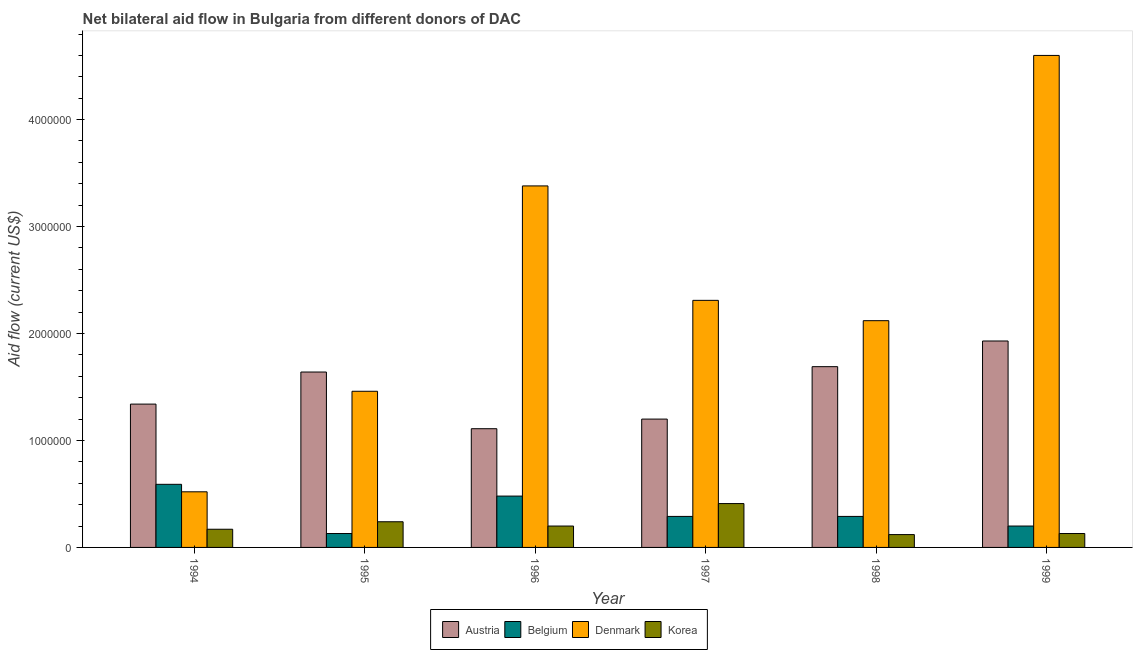How many groups of bars are there?
Keep it short and to the point. 6. Are the number of bars per tick equal to the number of legend labels?
Ensure brevity in your answer.  Yes. Are the number of bars on each tick of the X-axis equal?
Offer a terse response. Yes. How many bars are there on the 6th tick from the left?
Provide a short and direct response. 4. How many bars are there on the 2nd tick from the right?
Ensure brevity in your answer.  4. What is the label of the 3rd group of bars from the left?
Offer a very short reply. 1996. In how many cases, is the number of bars for a given year not equal to the number of legend labels?
Give a very brief answer. 0. What is the amount of aid given by austria in 1998?
Give a very brief answer. 1.69e+06. Across all years, what is the maximum amount of aid given by austria?
Provide a succinct answer. 1.93e+06. Across all years, what is the minimum amount of aid given by denmark?
Make the answer very short. 5.20e+05. What is the total amount of aid given by korea in the graph?
Offer a very short reply. 1.27e+06. What is the difference between the amount of aid given by austria in 1994 and that in 1996?
Ensure brevity in your answer.  2.30e+05. What is the difference between the amount of aid given by denmark in 1995 and the amount of aid given by belgium in 1998?
Your answer should be very brief. -6.60e+05. What is the average amount of aid given by denmark per year?
Give a very brief answer. 2.40e+06. In how many years, is the amount of aid given by austria greater than 3200000 US$?
Give a very brief answer. 0. What is the ratio of the amount of aid given by korea in 1995 to that in 1997?
Provide a succinct answer. 0.59. Is the amount of aid given by belgium in 1996 less than that in 1997?
Give a very brief answer. No. Is the difference between the amount of aid given by denmark in 1994 and 1995 greater than the difference between the amount of aid given by austria in 1994 and 1995?
Ensure brevity in your answer.  No. What is the difference between the highest and the lowest amount of aid given by denmark?
Give a very brief answer. 4.08e+06. Is the sum of the amount of aid given by korea in 1996 and 1998 greater than the maximum amount of aid given by austria across all years?
Your answer should be compact. No. What does the 3rd bar from the left in 1999 represents?
Give a very brief answer. Denmark. What does the 4th bar from the right in 1995 represents?
Your response must be concise. Austria. Are all the bars in the graph horizontal?
Make the answer very short. No. How many years are there in the graph?
Keep it short and to the point. 6. What is the difference between two consecutive major ticks on the Y-axis?
Offer a terse response. 1.00e+06. Does the graph contain any zero values?
Your response must be concise. No. Does the graph contain grids?
Ensure brevity in your answer.  No. How many legend labels are there?
Provide a short and direct response. 4. How are the legend labels stacked?
Offer a very short reply. Horizontal. What is the title of the graph?
Your answer should be compact. Net bilateral aid flow in Bulgaria from different donors of DAC. What is the Aid flow (current US$) of Austria in 1994?
Your response must be concise. 1.34e+06. What is the Aid flow (current US$) of Belgium in 1994?
Ensure brevity in your answer.  5.90e+05. What is the Aid flow (current US$) of Denmark in 1994?
Give a very brief answer. 5.20e+05. What is the Aid flow (current US$) of Austria in 1995?
Your answer should be very brief. 1.64e+06. What is the Aid flow (current US$) of Denmark in 1995?
Provide a succinct answer. 1.46e+06. What is the Aid flow (current US$) in Korea in 1995?
Give a very brief answer. 2.40e+05. What is the Aid flow (current US$) in Austria in 1996?
Make the answer very short. 1.11e+06. What is the Aid flow (current US$) of Belgium in 1996?
Offer a very short reply. 4.80e+05. What is the Aid flow (current US$) in Denmark in 1996?
Ensure brevity in your answer.  3.38e+06. What is the Aid flow (current US$) in Austria in 1997?
Provide a succinct answer. 1.20e+06. What is the Aid flow (current US$) in Belgium in 1997?
Provide a succinct answer. 2.90e+05. What is the Aid flow (current US$) in Denmark in 1997?
Provide a succinct answer. 2.31e+06. What is the Aid flow (current US$) in Austria in 1998?
Keep it short and to the point. 1.69e+06. What is the Aid flow (current US$) of Belgium in 1998?
Provide a succinct answer. 2.90e+05. What is the Aid flow (current US$) in Denmark in 1998?
Keep it short and to the point. 2.12e+06. What is the Aid flow (current US$) of Korea in 1998?
Give a very brief answer. 1.20e+05. What is the Aid flow (current US$) in Austria in 1999?
Offer a very short reply. 1.93e+06. What is the Aid flow (current US$) of Belgium in 1999?
Your response must be concise. 2.00e+05. What is the Aid flow (current US$) of Denmark in 1999?
Ensure brevity in your answer.  4.60e+06. Across all years, what is the maximum Aid flow (current US$) of Austria?
Offer a terse response. 1.93e+06. Across all years, what is the maximum Aid flow (current US$) of Belgium?
Give a very brief answer. 5.90e+05. Across all years, what is the maximum Aid flow (current US$) in Denmark?
Ensure brevity in your answer.  4.60e+06. Across all years, what is the minimum Aid flow (current US$) in Austria?
Your response must be concise. 1.11e+06. Across all years, what is the minimum Aid flow (current US$) in Denmark?
Provide a short and direct response. 5.20e+05. Across all years, what is the minimum Aid flow (current US$) of Korea?
Keep it short and to the point. 1.20e+05. What is the total Aid flow (current US$) of Austria in the graph?
Make the answer very short. 8.91e+06. What is the total Aid flow (current US$) of Belgium in the graph?
Offer a terse response. 1.98e+06. What is the total Aid flow (current US$) in Denmark in the graph?
Offer a very short reply. 1.44e+07. What is the total Aid flow (current US$) of Korea in the graph?
Offer a terse response. 1.27e+06. What is the difference between the Aid flow (current US$) in Denmark in 1994 and that in 1995?
Provide a short and direct response. -9.40e+05. What is the difference between the Aid flow (current US$) of Korea in 1994 and that in 1995?
Your answer should be compact. -7.00e+04. What is the difference between the Aid flow (current US$) of Belgium in 1994 and that in 1996?
Your answer should be compact. 1.10e+05. What is the difference between the Aid flow (current US$) of Denmark in 1994 and that in 1996?
Your answer should be very brief. -2.86e+06. What is the difference between the Aid flow (current US$) in Korea in 1994 and that in 1996?
Offer a terse response. -3.00e+04. What is the difference between the Aid flow (current US$) of Belgium in 1994 and that in 1997?
Your answer should be compact. 3.00e+05. What is the difference between the Aid flow (current US$) of Denmark in 1994 and that in 1997?
Your response must be concise. -1.79e+06. What is the difference between the Aid flow (current US$) in Austria in 1994 and that in 1998?
Make the answer very short. -3.50e+05. What is the difference between the Aid flow (current US$) of Belgium in 1994 and that in 1998?
Your answer should be compact. 3.00e+05. What is the difference between the Aid flow (current US$) in Denmark in 1994 and that in 1998?
Keep it short and to the point. -1.60e+06. What is the difference between the Aid flow (current US$) of Austria in 1994 and that in 1999?
Keep it short and to the point. -5.90e+05. What is the difference between the Aid flow (current US$) in Denmark in 1994 and that in 1999?
Offer a very short reply. -4.08e+06. What is the difference between the Aid flow (current US$) of Austria in 1995 and that in 1996?
Offer a very short reply. 5.30e+05. What is the difference between the Aid flow (current US$) of Belgium in 1995 and that in 1996?
Offer a very short reply. -3.50e+05. What is the difference between the Aid flow (current US$) in Denmark in 1995 and that in 1996?
Offer a terse response. -1.92e+06. What is the difference between the Aid flow (current US$) in Korea in 1995 and that in 1996?
Make the answer very short. 4.00e+04. What is the difference between the Aid flow (current US$) of Belgium in 1995 and that in 1997?
Offer a terse response. -1.60e+05. What is the difference between the Aid flow (current US$) of Denmark in 1995 and that in 1997?
Make the answer very short. -8.50e+05. What is the difference between the Aid flow (current US$) of Denmark in 1995 and that in 1998?
Give a very brief answer. -6.60e+05. What is the difference between the Aid flow (current US$) in Belgium in 1995 and that in 1999?
Provide a short and direct response. -7.00e+04. What is the difference between the Aid flow (current US$) in Denmark in 1995 and that in 1999?
Keep it short and to the point. -3.14e+06. What is the difference between the Aid flow (current US$) of Austria in 1996 and that in 1997?
Ensure brevity in your answer.  -9.00e+04. What is the difference between the Aid flow (current US$) of Belgium in 1996 and that in 1997?
Offer a very short reply. 1.90e+05. What is the difference between the Aid flow (current US$) in Denmark in 1996 and that in 1997?
Your answer should be very brief. 1.07e+06. What is the difference between the Aid flow (current US$) in Austria in 1996 and that in 1998?
Ensure brevity in your answer.  -5.80e+05. What is the difference between the Aid flow (current US$) in Belgium in 1996 and that in 1998?
Provide a short and direct response. 1.90e+05. What is the difference between the Aid flow (current US$) in Denmark in 1996 and that in 1998?
Offer a terse response. 1.26e+06. What is the difference between the Aid flow (current US$) of Korea in 1996 and that in 1998?
Offer a very short reply. 8.00e+04. What is the difference between the Aid flow (current US$) of Austria in 1996 and that in 1999?
Give a very brief answer. -8.20e+05. What is the difference between the Aid flow (current US$) of Denmark in 1996 and that in 1999?
Your answer should be very brief. -1.22e+06. What is the difference between the Aid flow (current US$) in Austria in 1997 and that in 1998?
Make the answer very short. -4.90e+05. What is the difference between the Aid flow (current US$) in Belgium in 1997 and that in 1998?
Your response must be concise. 0. What is the difference between the Aid flow (current US$) in Denmark in 1997 and that in 1998?
Provide a succinct answer. 1.90e+05. What is the difference between the Aid flow (current US$) of Korea in 1997 and that in 1998?
Your answer should be compact. 2.90e+05. What is the difference between the Aid flow (current US$) of Austria in 1997 and that in 1999?
Ensure brevity in your answer.  -7.30e+05. What is the difference between the Aid flow (current US$) in Belgium in 1997 and that in 1999?
Your response must be concise. 9.00e+04. What is the difference between the Aid flow (current US$) of Denmark in 1997 and that in 1999?
Provide a short and direct response. -2.29e+06. What is the difference between the Aid flow (current US$) in Austria in 1998 and that in 1999?
Your answer should be compact. -2.40e+05. What is the difference between the Aid flow (current US$) in Denmark in 1998 and that in 1999?
Ensure brevity in your answer.  -2.48e+06. What is the difference between the Aid flow (current US$) in Austria in 1994 and the Aid flow (current US$) in Belgium in 1995?
Ensure brevity in your answer.  1.21e+06. What is the difference between the Aid flow (current US$) in Austria in 1994 and the Aid flow (current US$) in Korea in 1995?
Offer a very short reply. 1.10e+06. What is the difference between the Aid flow (current US$) in Belgium in 1994 and the Aid flow (current US$) in Denmark in 1995?
Provide a succinct answer. -8.70e+05. What is the difference between the Aid flow (current US$) of Belgium in 1994 and the Aid flow (current US$) of Korea in 1995?
Your answer should be compact. 3.50e+05. What is the difference between the Aid flow (current US$) in Austria in 1994 and the Aid flow (current US$) in Belgium in 1996?
Give a very brief answer. 8.60e+05. What is the difference between the Aid flow (current US$) in Austria in 1994 and the Aid flow (current US$) in Denmark in 1996?
Offer a terse response. -2.04e+06. What is the difference between the Aid flow (current US$) in Austria in 1994 and the Aid flow (current US$) in Korea in 1996?
Provide a succinct answer. 1.14e+06. What is the difference between the Aid flow (current US$) of Belgium in 1994 and the Aid flow (current US$) of Denmark in 1996?
Your answer should be very brief. -2.79e+06. What is the difference between the Aid flow (current US$) in Belgium in 1994 and the Aid flow (current US$) in Korea in 1996?
Provide a succinct answer. 3.90e+05. What is the difference between the Aid flow (current US$) in Austria in 1994 and the Aid flow (current US$) in Belgium in 1997?
Give a very brief answer. 1.05e+06. What is the difference between the Aid flow (current US$) of Austria in 1994 and the Aid flow (current US$) of Denmark in 1997?
Provide a succinct answer. -9.70e+05. What is the difference between the Aid flow (current US$) in Austria in 1994 and the Aid flow (current US$) in Korea in 1997?
Make the answer very short. 9.30e+05. What is the difference between the Aid flow (current US$) of Belgium in 1994 and the Aid flow (current US$) of Denmark in 1997?
Offer a very short reply. -1.72e+06. What is the difference between the Aid flow (current US$) of Austria in 1994 and the Aid flow (current US$) of Belgium in 1998?
Offer a terse response. 1.05e+06. What is the difference between the Aid flow (current US$) of Austria in 1994 and the Aid flow (current US$) of Denmark in 1998?
Your response must be concise. -7.80e+05. What is the difference between the Aid flow (current US$) in Austria in 1994 and the Aid flow (current US$) in Korea in 1998?
Ensure brevity in your answer.  1.22e+06. What is the difference between the Aid flow (current US$) in Belgium in 1994 and the Aid flow (current US$) in Denmark in 1998?
Provide a short and direct response. -1.53e+06. What is the difference between the Aid flow (current US$) in Belgium in 1994 and the Aid flow (current US$) in Korea in 1998?
Offer a very short reply. 4.70e+05. What is the difference between the Aid flow (current US$) of Austria in 1994 and the Aid flow (current US$) of Belgium in 1999?
Keep it short and to the point. 1.14e+06. What is the difference between the Aid flow (current US$) of Austria in 1994 and the Aid flow (current US$) of Denmark in 1999?
Ensure brevity in your answer.  -3.26e+06. What is the difference between the Aid flow (current US$) in Austria in 1994 and the Aid flow (current US$) in Korea in 1999?
Ensure brevity in your answer.  1.21e+06. What is the difference between the Aid flow (current US$) of Belgium in 1994 and the Aid flow (current US$) of Denmark in 1999?
Provide a short and direct response. -4.01e+06. What is the difference between the Aid flow (current US$) in Austria in 1995 and the Aid flow (current US$) in Belgium in 1996?
Offer a terse response. 1.16e+06. What is the difference between the Aid flow (current US$) of Austria in 1995 and the Aid flow (current US$) of Denmark in 1996?
Keep it short and to the point. -1.74e+06. What is the difference between the Aid flow (current US$) of Austria in 1995 and the Aid flow (current US$) of Korea in 1996?
Your answer should be compact. 1.44e+06. What is the difference between the Aid flow (current US$) in Belgium in 1995 and the Aid flow (current US$) in Denmark in 1996?
Your response must be concise. -3.25e+06. What is the difference between the Aid flow (current US$) in Belgium in 1995 and the Aid flow (current US$) in Korea in 1996?
Offer a terse response. -7.00e+04. What is the difference between the Aid flow (current US$) of Denmark in 1995 and the Aid flow (current US$) of Korea in 1996?
Make the answer very short. 1.26e+06. What is the difference between the Aid flow (current US$) of Austria in 1995 and the Aid flow (current US$) of Belgium in 1997?
Your answer should be compact. 1.35e+06. What is the difference between the Aid flow (current US$) of Austria in 1995 and the Aid flow (current US$) of Denmark in 1997?
Make the answer very short. -6.70e+05. What is the difference between the Aid flow (current US$) of Austria in 1995 and the Aid flow (current US$) of Korea in 1997?
Keep it short and to the point. 1.23e+06. What is the difference between the Aid flow (current US$) of Belgium in 1995 and the Aid flow (current US$) of Denmark in 1997?
Provide a short and direct response. -2.18e+06. What is the difference between the Aid flow (current US$) of Belgium in 1995 and the Aid flow (current US$) of Korea in 1997?
Provide a short and direct response. -2.80e+05. What is the difference between the Aid flow (current US$) of Denmark in 1995 and the Aid flow (current US$) of Korea in 1997?
Provide a succinct answer. 1.05e+06. What is the difference between the Aid flow (current US$) of Austria in 1995 and the Aid flow (current US$) of Belgium in 1998?
Offer a very short reply. 1.35e+06. What is the difference between the Aid flow (current US$) in Austria in 1995 and the Aid flow (current US$) in Denmark in 1998?
Your answer should be very brief. -4.80e+05. What is the difference between the Aid flow (current US$) in Austria in 1995 and the Aid flow (current US$) in Korea in 1998?
Give a very brief answer. 1.52e+06. What is the difference between the Aid flow (current US$) of Belgium in 1995 and the Aid flow (current US$) of Denmark in 1998?
Your answer should be compact. -1.99e+06. What is the difference between the Aid flow (current US$) of Denmark in 1995 and the Aid flow (current US$) of Korea in 1998?
Ensure brevity in your answer.  1.34e+06. What is the difference between the Aid flow (current US$) in Austria in 1995 and the Aid flow (current US$) in Belgium in 1999?
Make the answer very short. 1.44e+06. What is the difference between the Aid flow (current US$) in Austria in 1995 and the Aid flow (current US$) in Denmark in 1999?
Your answer should be very brief. -2.96e+06. What is the difference between the Aid flow (current US$) in Austria in 1995 and the Aid flow (current US$) in Korea in 1999?
Give a very brief answer. 1.51e+06. What is the difference between the Aid flow (current US$) in Belgium in 1995 and the Aid flow (current US$) in Denmark in 1999?
Your response must be concise. -4.47e+06. What is the difference between the Aid flow (current US$) in Denmark in 1995 and the Aid flow (current US$) in Korea in 1999?
Make the answer very short. 1.33e+06. What is the difference between the Aid flow (current US$) in Austria in 1996 and the Aid flow (current US$) in Belgium in 1997?
Offer a very short reply. 8.20e+05. What is the difference between the Aid flow (current US$) of Austria in 1996 and the Aid flow (current US$) of Denmark in 1997?
Your answer should be compact. -1.20e+06. What is the difference between the Aid flow (current US$) of Austria in 1996 and the Aid flow (current US$) of Korea in 1997?
Offer a very short reply. 7.00e+05. What is the difference between the Aid flow (current US$) of Belgium in 1996 and the Aid flow (current US$) of Denmark in 1997?
Your response must be concise. -1.83e+06. What is the difference between the Aid flow (current US$) in Denmark in 1996 and the Aid flow (current US$) in Korea in 1997?
Your response must be concise. 2.97e+06. What is the difference between the Aid flow (current US$) of Austria in 1996 and the Aid flow (current US$) of Belgium in 1998?
Offer a very short reply. 8.20e+05. What is the difference between the Aid flow (current US$) in Austria in 1996 and the Aid flow (current US$) in Denmark in 1998?
Give a very brief answer. -1.01e+06. What is the difference between the Aid flow (current US$) in Austria in 1996 and the Aid flow (current US$) in Korea in 1998?
Your answer should be compact. 9.90e+05. What is the difference between the Aid flow (current US$) of Belgium in 1996 and the Aid flow (current US$) of Denmark in 1998?
Your response must be concise. -1.64e+06. What is the difference between the Aid flow (current US$) of Belgium in 1996 and the Aid flow (current US$) of Korea in 1998?
Your answer should be very brief. 3.60e+05. What is the difference between the Aid flow (current US$) in Denmark in 1996 and the Aid flow (current US$) in Korea in 1998?
Your answer should be very brief. 3.26e+06. What is the difference between the Aid flow (current US$) of Austria in 1996 and the Aid flow (current US$) of Belgium in 1999?
Provide a succinct answer. 9.10e+05. What is the difference between the Aid flow (current US$) of Austria in 1996 and the Aid flow (current US$) of Denmark in 1999?
Provide a short and direct response. -3.49e+06. What is the difference between the Aid flow (current US$) in Austria in 1996 and the Aid flow (current US$) in Korea in 1999?
Provide a short and direct response. 9.80e+05. What is the difference between the Aid flow (current US$) of Belgium in 1996 and the Aid flow (current US$) of Denmark in 1999?
Offer a terse response. -4.12e+06. What is the difference between the Aid flow (current US$) of Denmark in 1996 and the Aid flow (current US$) of Korea in 1999?
Give a very brief answer. 3.25e+06. What is the difference between the Aid flow (current US$) in Austria in 1997 and the Aid flow (current US$) in Belgium in 1998?
Your response must be concise. 9.10e+05. What is the difference between the Aid flow (current US$) in Austria in 1997 and the Aid flow (current US$) in Denmark in 1998?
Provide a succinct answer. -9.20e+05. What is the difference between the Aid flow (current US$) of Austria in 1997 and the Aid flow (current US$) of Korea in 1998?
Your response must be concise. 1.08e+06. What is the difference between the Aid flow (current US$) of Belgium in 1997 and the Aid flow (current US$) of Denmark in 1998?
Offer a very short reply. -1.83e+06. What is the difference between the Aid flow (current US$) of Belgium in 1997 and the Aid flow (current US$) of Korea in 1998?
Keep it short and to the point. 1.70e+05. What is the difference between the Aid flow (current US$) in Denmark in 1997 and the Aid flow (current US$) in Korea in 1998?
Your answer should be very brief. 2.19e+06. What is the difference between the Aid flow (current US$) in Austria in 1997 and the Aid flow (current US$) in Denmark in 1999?
Your answer should be compact. -3.40e+06. What is the difference between the Aid flow (current US$) in Austria in 1997 and the Aid flow (current US$) in Korea in 1999?
Offer a terse response. 1.07e+06. What is the difference between the Aid flow (current US$) of Belgium in 1997 and the Aid flow (current US$) of Denmark in 1999?
Offer a very short reply. -4.31e+06. What is the difference between the Aid flow (current US$) in Belgium in 1997 and the Aid flow (current US$) in Korea in 1999?
Your answer should be very brief. 1.60e+05. What is the difference between the Aid flow (current US$) in Denmark in 1997 and the Aid flow (current US$) in Korea in 1999?
Your response must be concise. 2.18e+06. What is the difference between the Aid flow (current US$) of Austria in 1998 and the Aid flow (current US$) of Belgium in 1999?
Ensure brevity in your answer.  1.49e+06. What is the difference between the Aid flow (current US$) of Austria in 1998 and the Aid flow (current US$) of Denmark in 1999?
Your response must be concise. -2.91e+06. What is the difference between the Aid flow (current US$) of Austria in 1998 and the Aid flow (current US$) of Korea in 1999?
Provide a succinct answer. 1.56e+06. What is the difference between the Aid flow (current US$) of Belgium in 1998 and the Aid flow (current US$) of Denmark in 1999?
Keep it short and to the point. -4.31e+06. What is the difference between the Aid flow (current US$) of Belgium in 1998 and the Aid flow (current US$) of Korea in 1999?
Offer a very short reply. 1.60e+05. What is the difference between the Aid flow (current US$) in Denmark in 1998 and the Aid flow (current US$) in Korea in 1999?
Give a very brief answer. 1.99e+06. What is the average Aid flow (current US$) of Austria per year?
Your response must be concise. 1.48e+06. What is the average Aid flow (current US$) in Belgium per year?
Your answer should be very brief. 3.30e+05. What is the average Aid flow (current US$) of Denmark per year?
Make the answer very short. 2.40e+06. What is the average Aid flow (current US$) in Korea per year?
Your answer should be very brief. 2.12e+05. In the year 1994, what is the difference between the Aid flow (current US$) in Austria and Aid flow (current US$) in Belgium?
Offer a very short reply. 7.50e+05. In the year 1994, what is the difference between the Aid flow (current US$) in Austria and Aid flow (current US$) in Denmark?
Your answer should be very brief. 8.20e+05. In the year 1994, what is the difference between the Aid flow (current US$) of Austria and Aid flow (current US$) of Korea?
Ensure brevity in your answer.  1.17e+06. In the year 1994, what is the difference between the Aid flow (current US$) in Belgium and Aid flow (current US$) in Denmark?
Keep it short and to the point. 7.00e+04. In the year 1994, what is the difference between the Aid flow (current US$) of Belgium and Aid flow (current US$) of Korea?
Offer a terse response. 4.20e+05. In the year 1994, what is the difference between the Aid flow (current US$) in Denmark and Aid flow (current US$) in Korea?
Offer a very short reply. 3.50e+05. In the year 1995, what is the difference between the Aid flow (current US$) of Austria and Aid flow (current US$) of Belgium?
Keep it short and to the point. 1.51e+06. In the year 1995, what is the difference between the Aid flow (current US$) of Austria and Aid flow (current US$) of Korea?
Your answer should be very brief. 1.40e+06. In the year 1995, what is the difference between the Aid flow (current US$) in Belgium and Aid flow (current US$) in Denmark?
Give a very brief answer. -1.33e+06. In the year 1995, what is the difference between the Aid flow (current US$) in Denmark and Aid flow (current US$) in Korea?
Provide a succinct answer. 1.22e+06. In the year 1996, what is the difference between the Aid flow (current US$) in Austria and Aid flow (current US$) in Belgium?
Offer a terse response. 6.30e+05. In the year 1996, what is the difference between the Aid flow (current US$) of Austria and Aid flow (current US$) of Denmark?
Your answer should be very brief. -2.27e+06. In the year 1996, what is the difference between the Aid flow (current US$) in Austria and Aid flow (current US$) in Korea?
Offer a terse response. 9.10e+05. In the year 1996, what is the difference between the Aid flow (current US$) of Belgium and Aid flow (current US$) of Denmark?
Offer a terse response. -2.90e+06. In the year 1996, what is the difference between the Aid flow (current US$) in Belgium and Aid flow (current US$) in Korea?
Provide a short and direct response. 2.80e+05. In the year 1996, what is the difference between the Aid flow (current US$) in Denmark and Aid flow (current US$) in Korea?
Keep it short and to the point. 3.18e+06. In the year 1997, what is the difference between the Aid flow (current US$) of Austria and Aid flow (current US$) of Belgium?
Provide a succinct answer. 9.10e+05. In the year 1997, what is the difference between the Aid flow (current US$) of Austria and Aid flow (current US$) of Denmark?
Keep it short and to the point. -1.11e+06. In the year 1997, what is the difference between the Aid flow (current US$) of Austria and Aid flow (current US$) of Korea?
Keep it short and to the point. 7.90e+05. In the year 1997, what is the difference between the Aid flow (current US$) in Belgium and Aid flow (current US$) in Denmark?
Ensure brevity in your answer.  -2.02e+06. In the year 1997, what is the difference between the Aid flow (current US$) in Denmark and Aid flow (current US$) in Korea?
Your answer should be very brief. 1.90e+06. In the year 1998, what is the difference between the Aid flow (current US$) in Austria and Aid flow (current US$) in Belgium?
Make the answer very short. 1.40e+06. In the year 1998, what is the difference between the Aid flow (current US$) in Austria and Aid flow (current US$) in Denmark?
Provide a short and direct response. -4.30e+05. In the year 1998, what is the difference between the Aid flow (current US$) in Austria and Aid flow (current US$) in Korea?
Provide a short and direct response. 1.57e+06. In the year 1998, what is the difference between the Aid flow (current US$) of Belgium and Aid flow (current US$) of Denmark?
Give a very brief answer. -1.83e+06. In the year 1998, what is the difference between the Aid flow (current US$) in Belgium and Aid flow (current US$) in Korea?
Give a very brief answer. 1.70e+05. In the year 1998, what is the difference between the Aid flow (current US$) of Denmark and Aid flow (current US$) of Korea?
Offer a very short reply. 2.00e+06. In the year 1999, what is the difference between the Aid flow (current US$) in Austria and Aid flow (current US$) in Belgium?
Provide a short and direct response. 1.73e+06. In the year 1999, what is the difference between the Aid flow (current US$) of Austria and Aid flow (current US$) of Denmark?
Your answer should be very brief. -2.67e+06. In the year 1999, what is the difference between the Aid flow (current US$) of Austria and Aid flow (current US$) of Korea?
Your answer should be compact. 1.80e+06. In the year 1999, what is the difference between the Aid flow (current US$) of Belgium and Aid flow (current US$) of Denmark?
Your answer should be very brief. -4.40e+06. In the year 1999, what is the difference between the Aid flow (current US$) in Denmark and Aid flow (current US$) in Korea?
Your answer should be very brief. 4.47e+06. What is the ratio of the Aid flow (current US$) in Austria in 1994 to that in 1995?
Provide a short and direct response. 0.82. What is the ratio of the Aid flow (current US$) in Belgium in 1994 to that in 1995?
Make the answer very short. 4.54. What is the ratio of the Aid flow (current US$) in Denmark in 1994 to that in 1995?
Your answer should be compact. 0.36. What is the ratio of the Aid flow (current US$) of Korea in 1994 to that in 1995?
Offer a very short reply. 0.71. What is the ratio of the Aid flow (current US$) in Austria in 1994 to that in 1996?
Your answer should be compact. 1.21. What is the ratio of the Aid flow (current US$) of Belgium in 1994 to that in 1996?
Your answer should be very brief. 1.23. What is the ratio of the Aid flow (current US$) of Denmark in 1994 to that in 1996?
Give a very brief answer. 0.15. What is the ratio of the Aid flow (current US$) of Korea in 1994 to that in 1996?
Offer a terse response. 0.85. What is the ratio of the Aid flow (current US$) of Austria in 1994 to that in 1997?
Offer a very short reply. 1.12. What is the ratio of the Aid flow (current US$) of Belgium in 1994 to that in 1997?
Provide a succinct answer. 2.03. What is the ratio of the Aid flow (current US$) in Denmark in 1994 to that in 1997?
Provide a succinct answer. 0.23. What is the ratio of the Aid flow (current US$) of Korea in 1994 to that in 1997?
Provide a short and direct response. 0.41. What is the ratio of the Aid flow (current US$) in Austria in 1994 to that in 1998?
Give a very brief answer. 0.79. What is the ratio of the Aid flow (current US$) of Belgium in 1994 to that in 1998?
Your answer should be compact. 2.03. What is the ratio of the Aid flow (current US$) of Denmark in 1994 to that in 1998?
Provide a succinct answer. 0.25. What is the ratio of the Aid flow (current US$) in Korea in 1994 to that in 1998?
Offer a terse response. 1.42. What is the ratio of the Aid flow (current US$) of Austria in 1994 to that in 1999?
Your answer should be compact. 0.69. What is the ratio of the Aid flow (current US$) of Belgium in 1994 to that in 1999?
Give a very brief answer. 2.95. What is the ratio of the Aid flow (current US$) in Denmark in 1994 to that in 1999?
Give a very brief answer. 0.11. What is the ratio of the Aid flow (current US$) in Korea in 1994 to that in 1999?
Offer a terse response. 1.31. What is the ratio of the Aid flow (current US$) in Austria in 1995 to that in 1996?
Your answer should be very brief. 1.48. What is the ratio of the Aid flow (current US$) in Belgium in 1995 to that in 1996?
Give a very brief answer. 0.27. What is the ratio of the Aid flow (current US$) of Denmark in 1995 to that in 1996?
Offer a very short reply. 0.43. What is the ratio of the Aid flow (current US$) in Austria in 1995 to that in 1997?
Keep it short and to the point. 1.37. What is the ratio of the Aid flow (current US$) of Belgium in 1995 to that in 1997?
Make the answer very short. 0.45. What is the ratio of the Aid flow (current US$) in Denmark in 1995 to that in 1997?
Provide a short and direct response. 0.63. What is the ratio of the Aid flow (current US$) of Korea in 1995 to that in 1997?
Provide a succinct answer. 0.59. What is the ratio of the Aid flow (current US$) of Austria in 1995 to that in 1998?
Your answer should be compact. 0.97. What is the ratio of the Aid flow (current US$) of Belgium in 1995 to that in 1998?
Provide a short and direct response. 0.45. What is the ratio of the Aid flow (current US$) of Denmark in 1995 to that in 1998?
Your answer should be compact. 0.69. What is the ratio of the Aid flow (current US$) in Austria in 1995 to that in 1999?
Your answer should be very brief. 0.85. What is the ratio of the Aid flow (current US$) in Belgium in 1995 to that in 1999?
Give a very brief answer. 0.65. What is the ratio of the Aid flow (current US$) in Denmark in 1995 to that in 1999?
Provide a short and direct response. 0.32. What is the ratio of the Aid flow (current US$) of Korea in 1995 to that in 1999?
Provide a short and direct response. 1.85. What is the ratio of the Aid flow (current US$) in Austria in 1996 to that in 1997?
Make the answer very short. 0.93. What is the ratio of the Aid flow (current US$) in Belgium in 1996 to that in 1997?
Give a very brief answer. 1.66. What is the ratio of the Aid flow (current US$) in Denmark in 1996 to that in 1997?
Provide a short and direct response. 1.46. What is the ratio of the Aid flow (current US$) in Korea in 1996 to that in 1997?
Provide a succinct answer. 0.49. What is the ratio of the Aid flow (current US$) of Austria in 1996 to that in 1998?
Provide a short and direct response. 0.66. What is the ratio of the Aid flow (current US$) of Belgium in 1996 to that in 1998?
Keep it short and to the point. 1.66. What is the ratio of the Aid flow (current US$) of Denmark in 1996 to that in 1998?
Make the answer very short. 1.59. What is the ratio of the Aid flow (current US$) of Korea in 1996 to that in 1998?
Your answer should be very brief. 1.67. What is the ratio of the Aid flow (current US$) in Austria in 1996 to that in 1999?
Ensure brevity in your answer.  0.58. What is the ratio of the Aid flow (current US$) of Belgium in 1996 to that in 1999?
Give a very brief answer. 2.4. What is the ratio of the Aid flow (current US$) of Denmark in 1996 to that in 1999?
Offer a very short reply. 0.73. What is the ratio of the Aid flow (current US$) of Korea in 1996 to that in 1999?
Provide a short and direct response. 1.54. What is the ratio of the Aid flow (current US$) in Austria in 1997 to that in 1998?
Make the answer very short. 0.71. What is the ratio of the Aid flow (current US$) in Belgium in 1997 to that in 1998?
Offer a very short reply. 1. What is the ratio of the Aid flow (current US$) of Denmark in 1997 to that in 1998?
Give a very brief answer. 1.09. What is the ratio of the Aid flow (current US$) in Korea in 1997 to that in 1998?
Provide a succinct answer. 3.42. What is the ratio of the Aid flow (current US$) in Austria in 1997 to that in 1999?
Keep it short and to the point. 0.62. What is the ratio of the Aid flow (current US$) of Belgium in 1997 to that in 1999?
Provide a short and direct response. 1.45. What is the ratio of the Aid flow (current US$) in Denmark in 1997 to that in 1999?
Provide a succinct answer. 0.5. What is the ratio of the Aid flow (current US$) of Korea in 1997 to that in 1999?
Your answer should be very brief. 3.15. What is the ratio of the Aid flow (current US$) of Austria in 1998 to that in 1999?
Provide a short and direct response. 0.88. What is the ratio of the Aid flow (current US$) in Belgium in 1998 to that in 1999?
Offer a terse response. 1.45. What is the ratio of the Aid flow (current US$) in Denmark in 1998 to that in 1999?
Offer a very short reply. 0.46. What is the difference between the highest and the second highest Aid flow (current US$) of Belgium?
Your answer should be very brief. 1.10e+05. What is the difference between the highest and the second highest Aid flow (current US$) in Denmark?
Provide a succinct answer. 1.22e+06. What is the difference between the highest and the second highest Aid flow (current US$) of Korea?
Give a very brief answer. 1.70e+05. What is the difference between the highest and the lowest Aid flow (current US$) in Austria?
Make the answer very short. 8.20e+05. What is the difference between the highest and the lowest Aid flow (current US$) in Denmark?
Offer a very short reply. 4.08e+06. 